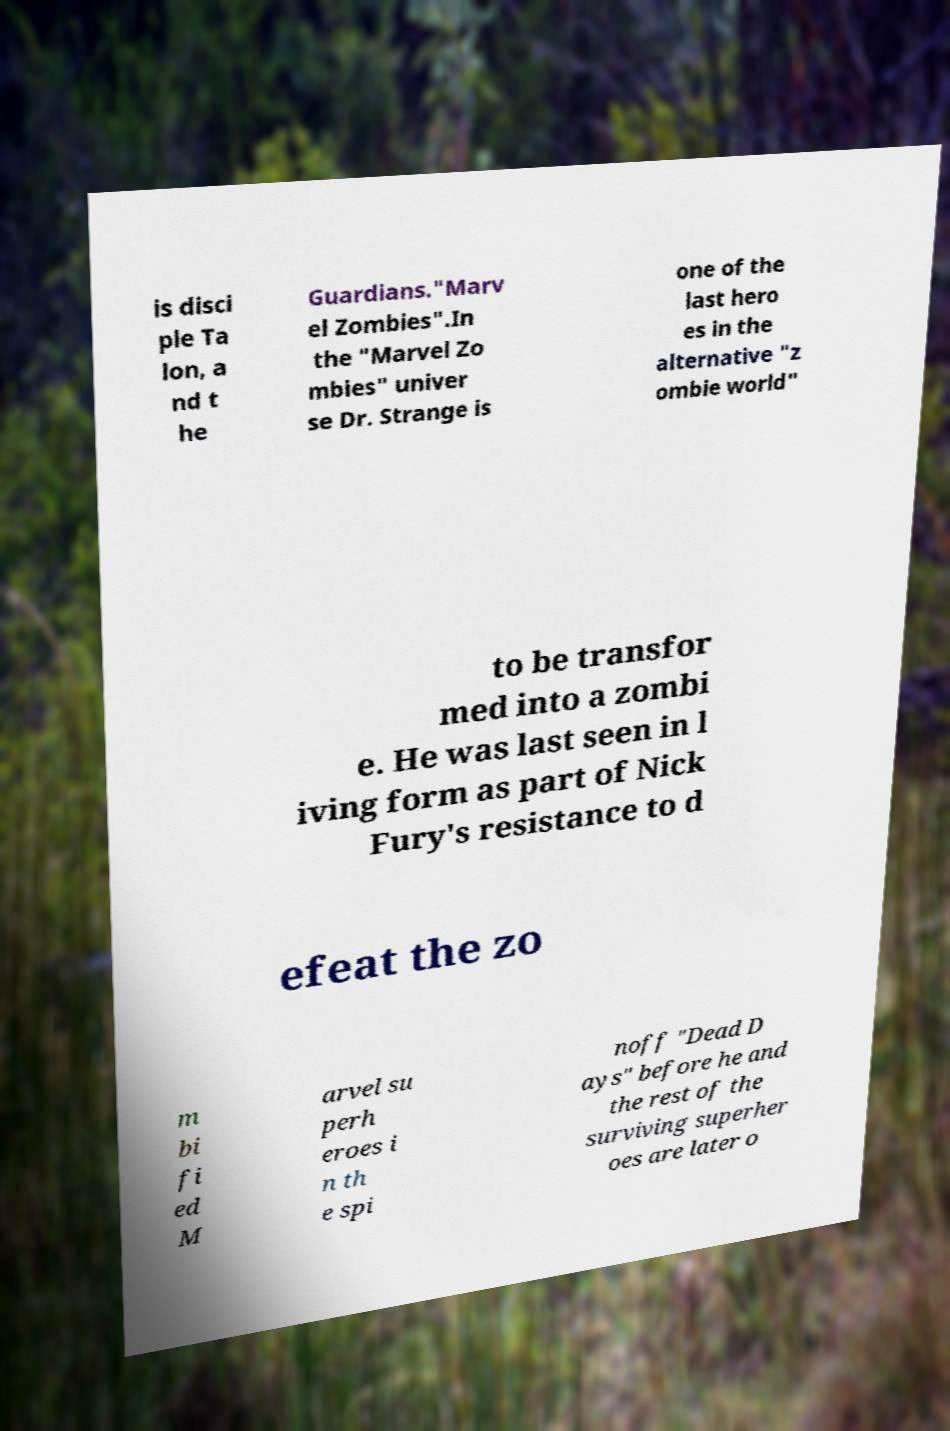Could you assist in decoding the text presented in this image and type it out clearly? is disci ple Ta lon, a nd t he Guardians."Marv el Zombies".In the "Marvel Zo mbies" univer se Dr. Strange is one of the last hero es in the alternative "z ombie world" to be transfor med into a zombi e. He was last seen in l iving form as part of Nick Fury's resistance to d efeat the zo m bi fi ed M arvel su perh eroes i n th e spi noff "Dead D ays" before he and the rest of the surviving superher oes are later o 